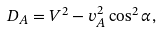Convert formula to latex. <formula><loc_0><loc_0><loc_500><loc_500>D _ { A } = V ^ { 2 } - v _ { A } ^ { 2 } \cos ^ { 2 } \alpha ,</formula> 